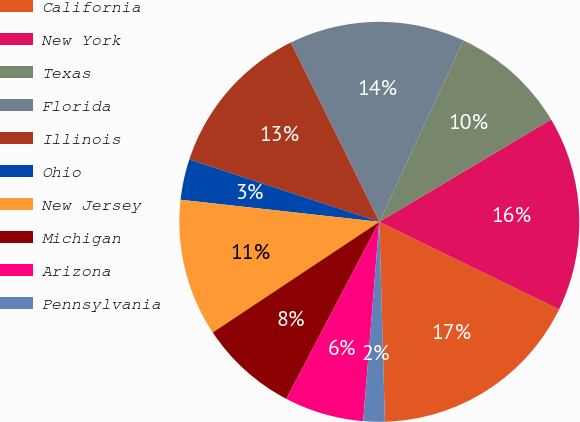<chart> <loc_0><loc_0><loc_500><loc_500><pie_chart><fcel>California<fcel>New York<fcel>Texas<fcel>Florida<fcel>Illinois<fcel>Ohio<fcel>New Jersey<fcel>Michigan<fcel>Arizona<fcel>Pennsylvania<nl><fcel>17.33%<fcel>15.77%<fcel>9.53%<fcel>14.21%<fcel>12.65%<fcel>3.29%<fcel>11.09%<fcel>7.97%<fcel>6.41%<fcel>1.73%<nl></chart> 